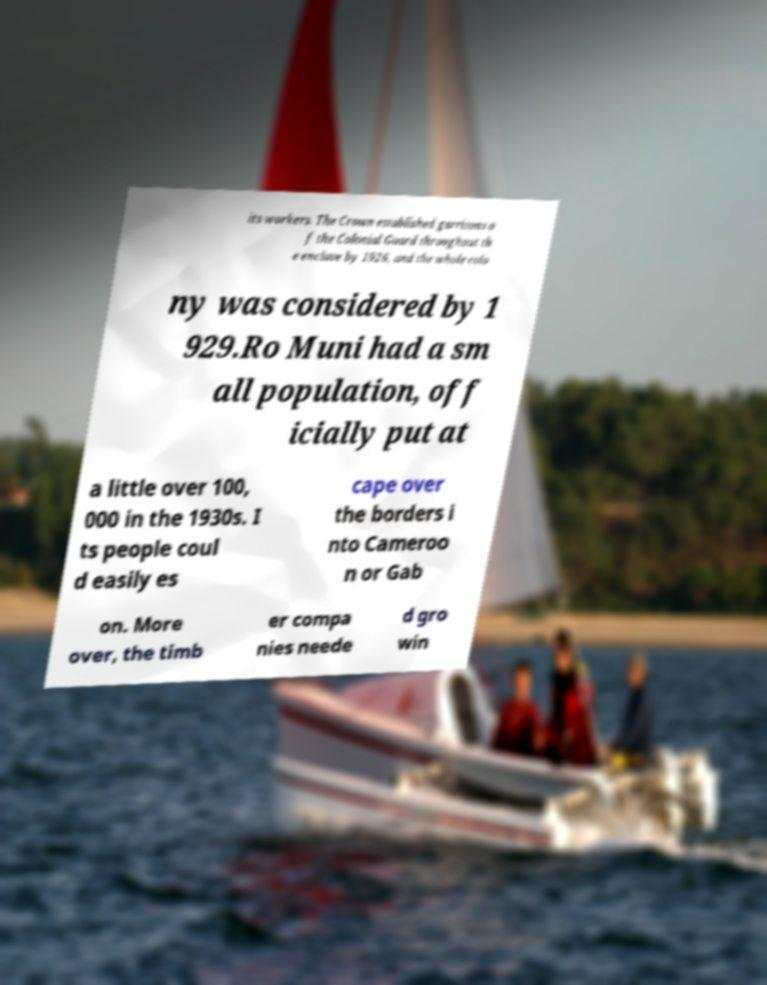Can you accurately transcribe the text from the provided image for me? its workers. The Crown established garrisons o f the Colonial Guard throughout th e enclave by 1926, and the whole colo ny was considered by 1 929.Ro Muni had a sm all population, off icially put at a little over 100, 000 in the 1930s. I ts people coul d easily es cape over the borders i nto Cameroo n or Gab on. More over, the timb er compa nies neede d gro win 